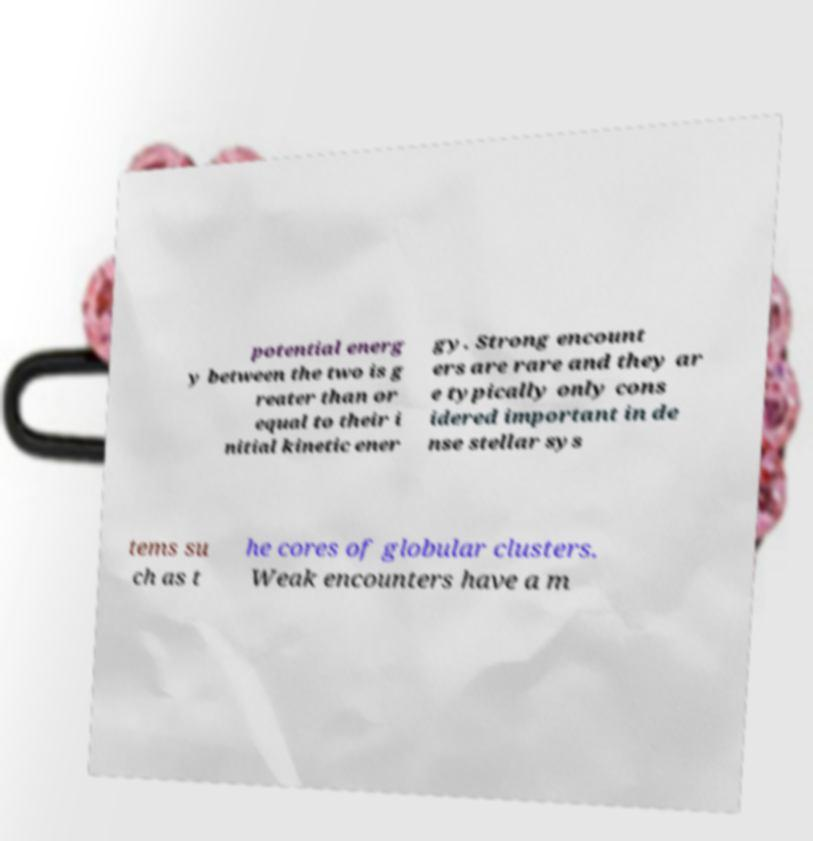I need the written content from this picture converted into text. Can you do that? potential energ y between the two is g reater than or equal to their i nitial kinetic ener gy. Strong encount ers are rare and they ar e typically only cons idered important in de nse stellar sys tems su ch as t he cores of globular clusters. Weak encounters have a m 